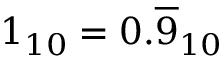Convert formula to latex. <formula><loc_0><loc_0><loc_500><loc_500>1 _ { 1 0 } = 0 . { \overline { 9 } } _ { 1 0 }</formula> 